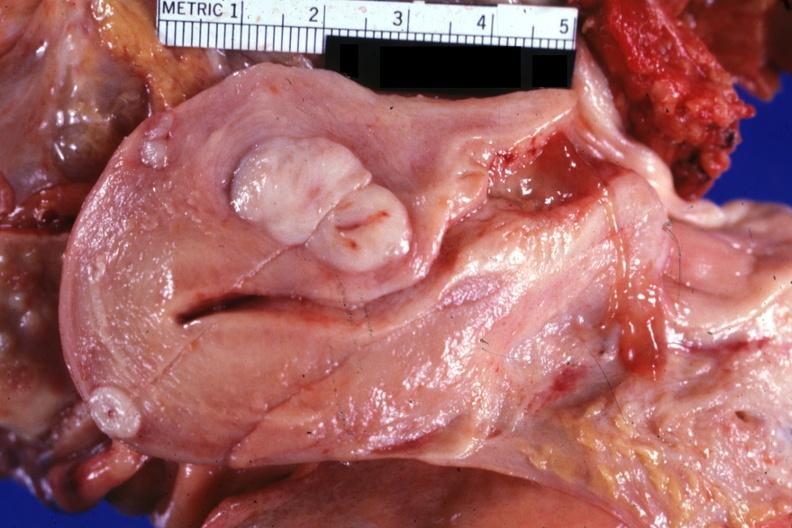what does this image show?
Answer the question using a single word or phrase. Opened uterus with three myomas quite typical 